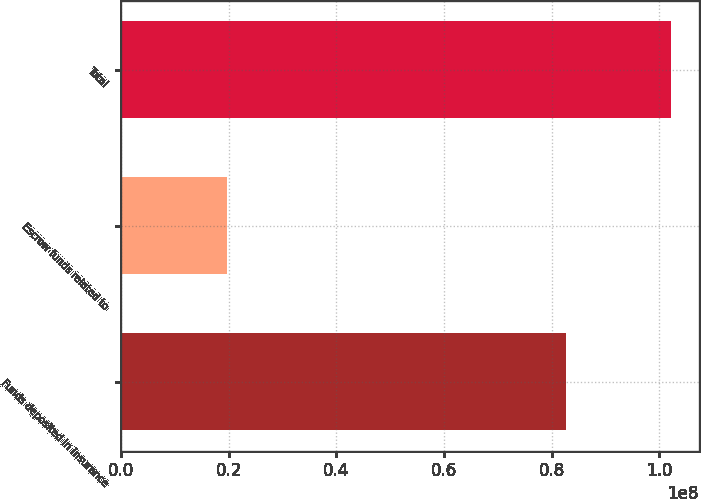<chart> <loc_0><loc_0><loc_500><loc_500><bar_chart><fcel>Funds deposited in insurance<fcel>Escrow funds related to<fcel>Total<nl><fcel>8.2653e+07<fcel>1.9621e+07<fcel>1.02274e+08<nl></chart> 